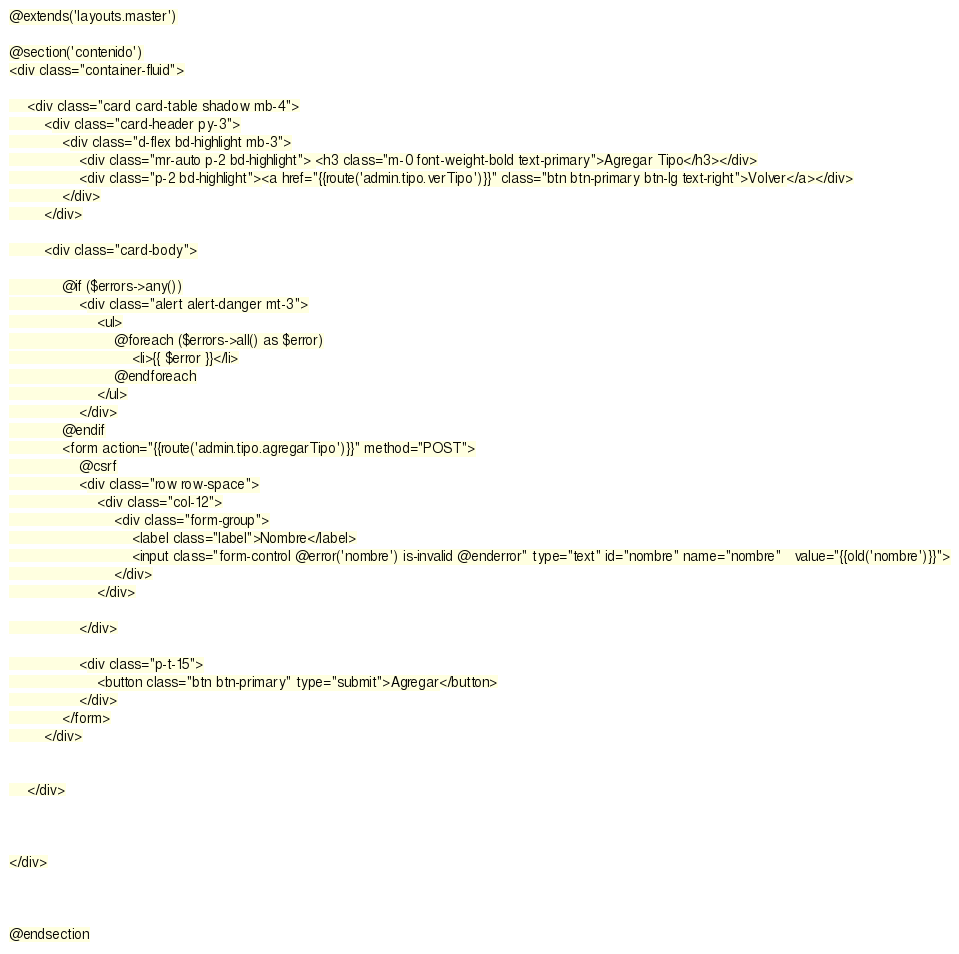<code> <loc_0><loc_0><loc_500><loc_500><_PHP_>@extends('layouts.master')

@section('contenido')
<div class="container-fluid">

    <div class="card card-table shadow mb-4">
        <div class="card-header py-3">
            <div class="d-flex bd-highlight mb-3">
                <div class="mr-auto p-2 bd-highlight"> <h3 class="m-0 font-weight-bold text-primary">Agregar Tipo</h3></div>
                <div class="p-2 bd-highlight"><a href="{{route('admin.tipo.verTipo')}}" class="btn btn-primary btn-lg text-right">Volver</a></div>
            </div>
        </div>

        <div class="card-body">

            @if ($errors->any())
                <div class="alert alert-danger mt-3">
                    <ul>
                        @foreach ($errors->all() as $error)
                            <li>{{ $error }}</li>
                        @endforeach
                    </ul>
                </div>
            @endif
            <form action="{{route('admin.tipo.agregarTipo')}}" method="POST">
                @csrf
                <div class="row row-space">
                    <div class="col-12">
                        <div class="form-group">
                            <label class="label">Nombre</label>
                            <input class="form-control @error('nombre') is-invalid @enderror" type="text" id="nombre" name="nombre"   value="{{old('nombre')}}">
                        </div>
                    </div>

                </div>

                <div class="p-t-15">
                    <button class="btn btn-primary" type="submit">Agregar</button>
                </div>
            </form>
        </div>


    </div>



</div>



@endsection
</code> 